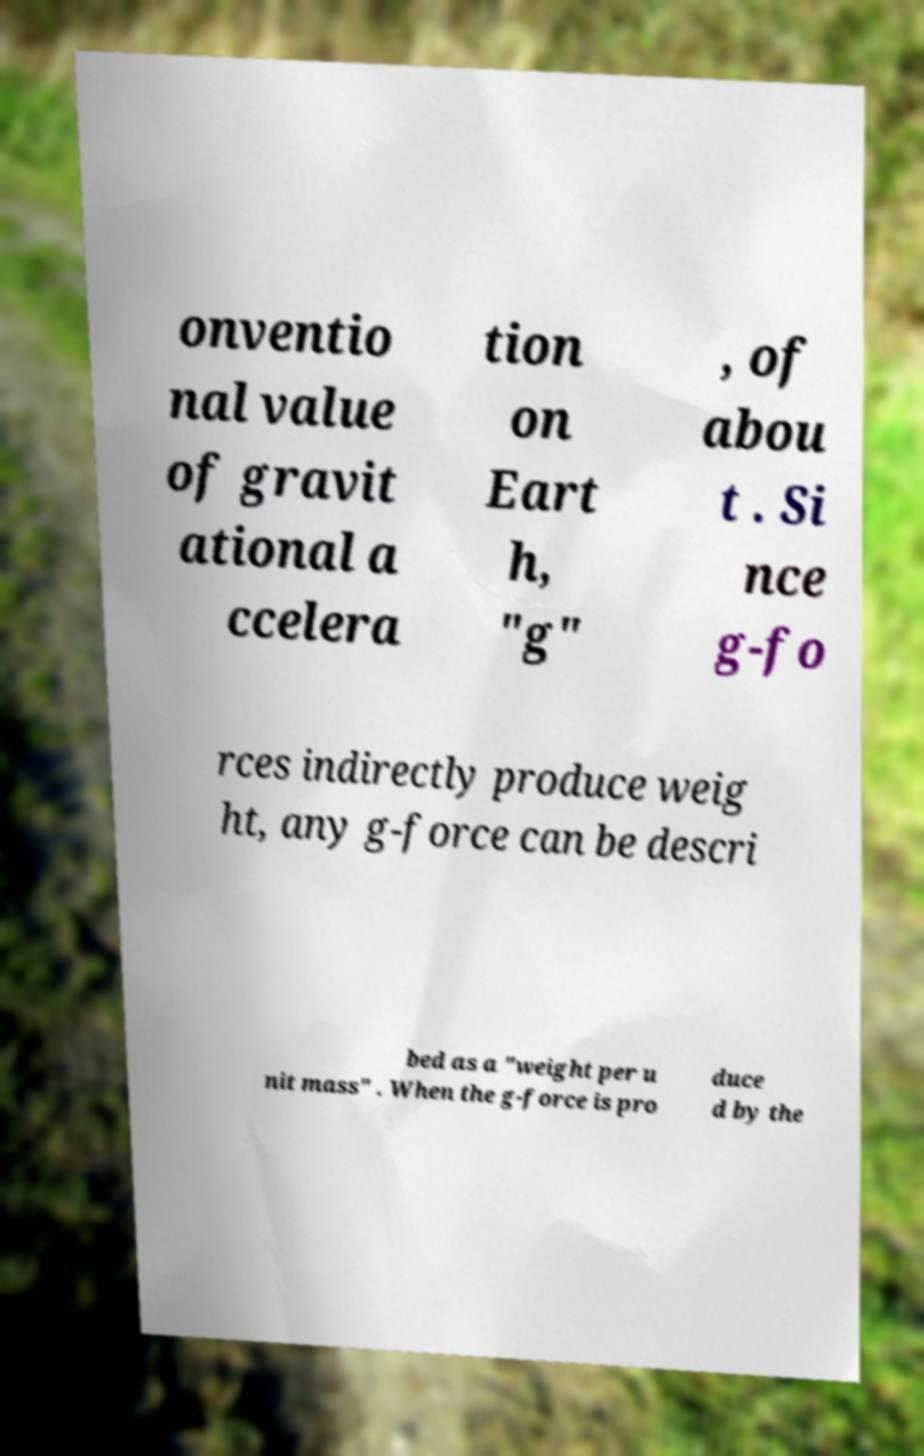Can you accurately transcribe the text from the provided image for me? onventio nal value of gravit ational a ccelera tion on Eart h, "g" , of abou t . Si nce g-fo rces indirectly produce weig ht, any g-force can be descri bed as a "weight per u nit mass" . When the g-force is pro duce d by the 